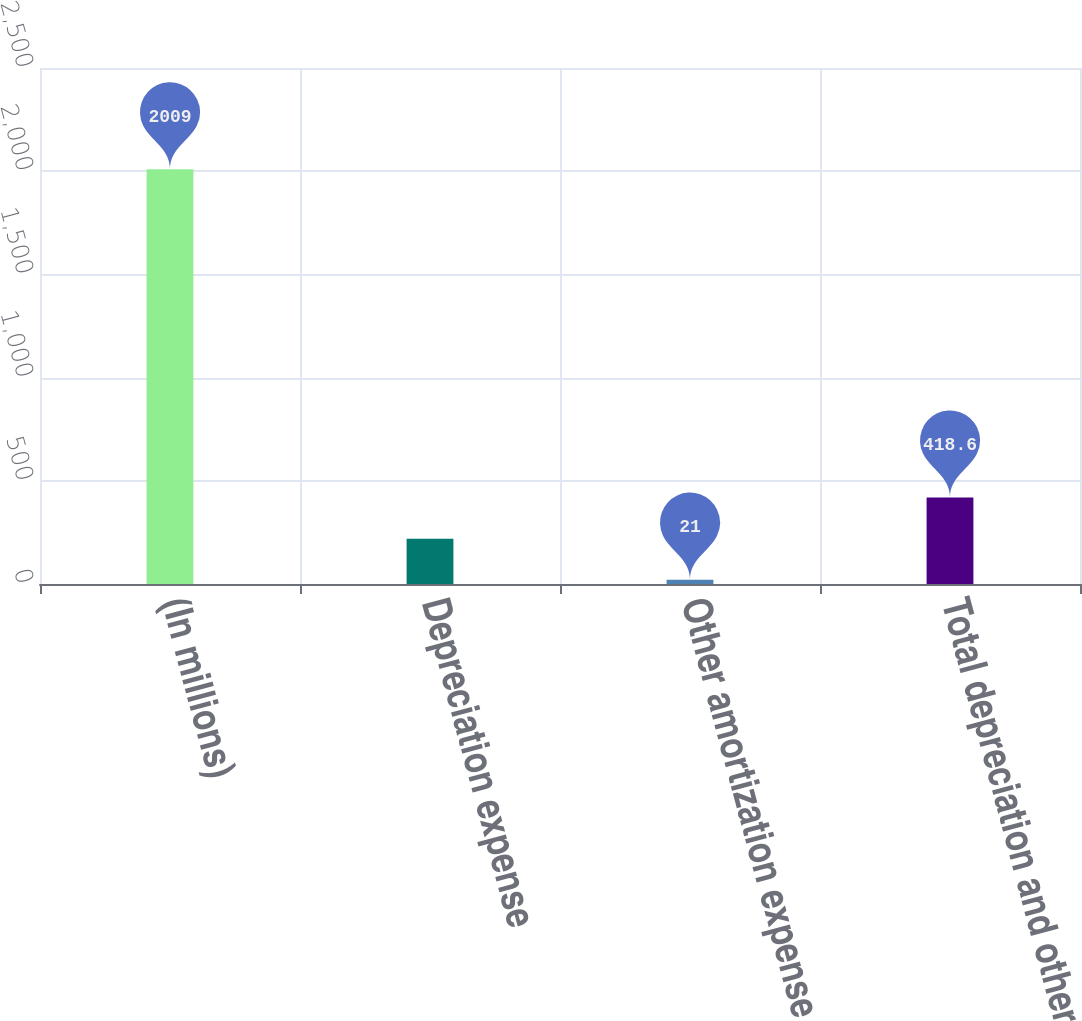Convert chart. <chart><loc_0><loc_0><loc_500><loc_500><bar_chart><fcel>(In millions)<fcel>Depreciation expense<fcel>Other amortization expense<fcel>Total depreciation and other<nl><fcel>2009<fcel>219.8<fcel>21<fcel>418.6<nl></chart> 